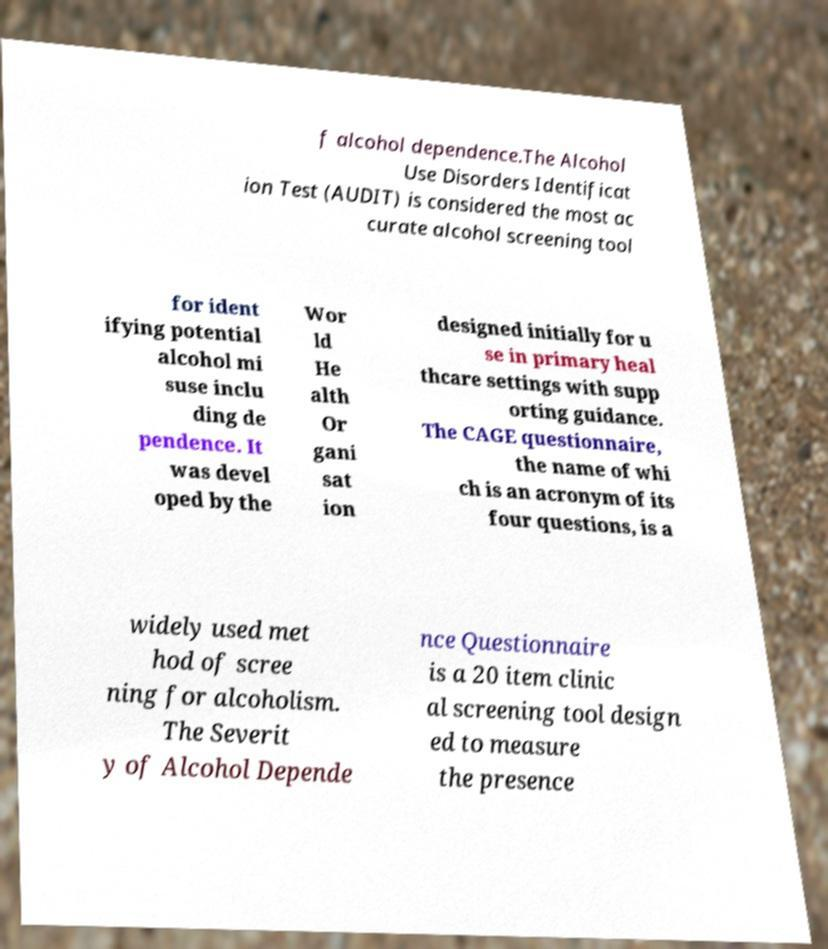I need the written content from this picture converted into text. Can you do that? f alcohol dependence.The Alcohol Use Disorders Identificat ion Test (AUDIT) is considered the most ac curate alcohol screening tool for ident ifying potential alcohol mi suse inclu ding de pendence. It was devel oped by the Wor ld He alth Or gani sat ion designed initially for u se in primary heal thcare settings with supp orting guidance. The CAGE questionnaire, the name of whi ch is an acronym of its four questions, is a widely used met hod of scree ning for alcoholism. The Severit y of Alcohol Depende nce Questionnaire is a 20 item clinic al screening tool design ed to measure the presence 